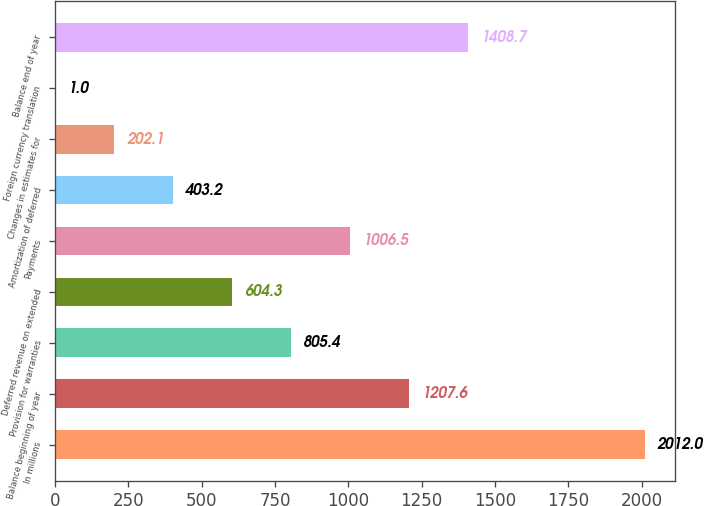Convert chart. <chart><loc_0><loc_0><loc_500><loc_500><bar_chart><fcel>In millions<fcel>Balance beginning of year<fcel>Provision for warranties<fcel>Deferred revenue on extended<fcel>Payments<fcel>Amortization of deferred<fcel>Changes in estimates for<fcel>Foreign currency translation<fcel>Balance end of year<nl><fcel>2012<fcel>1207.6<fcel>805.4<fcel>604.3<fcel>1006.5<fcel>403.2<fcel>202.1<fcel>1<fcel>1408.7<nl></chart> 